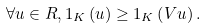Convert formula to latex. <formula><loc_0><loc_0><loc_500><loc_500>\forall u \in R , 1 _ { K } \left ( u \right ) \geq 1 _ { K } \left ( V u \right ) .</formula> 